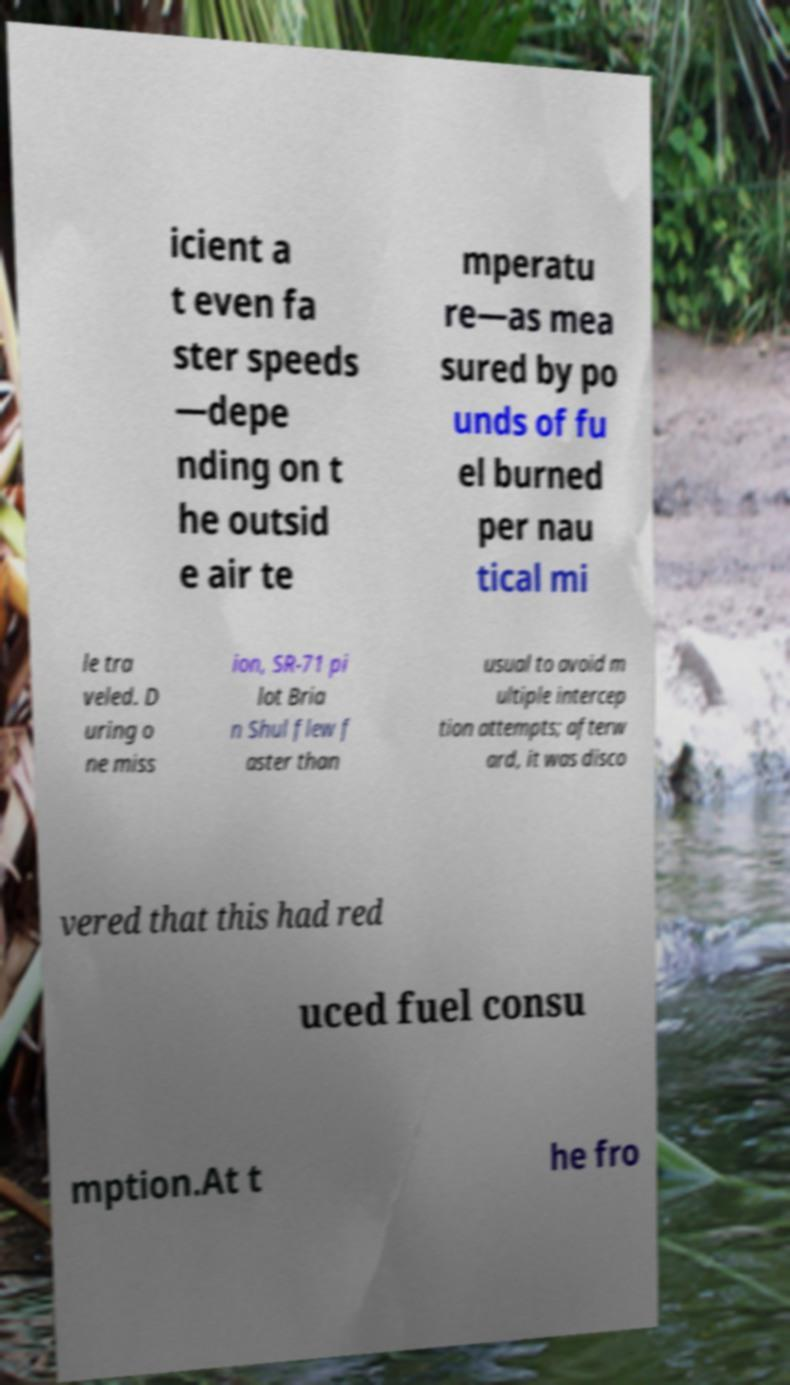There's text embedded in this image that I need extracted. Can you transcribe it verbatim? icient a t even fa ster speeds —depe nding on t he outsid e air te mperatu re—as mea sured by po unds of fu el burned per nau tical mi le tra veled. D uring o ne miss ion, SR-71 pi lot Bria n Shul flew f aster than usual to avoid m ultiple intercep tion attempts; afterw ard, it was disco vered that this had red uced fuel consu mption.At t he fro 